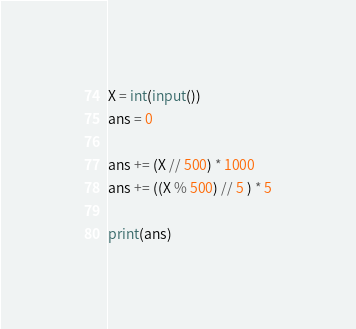Convert code to text. <code><loc_0><loc_0><loc_500><loc_500><_Python_>X = int(input())
ans = 0 

ans += (X // 500) * 1000
ans += ((X % 500) // 5 ) * 5

print(ans)</code> 